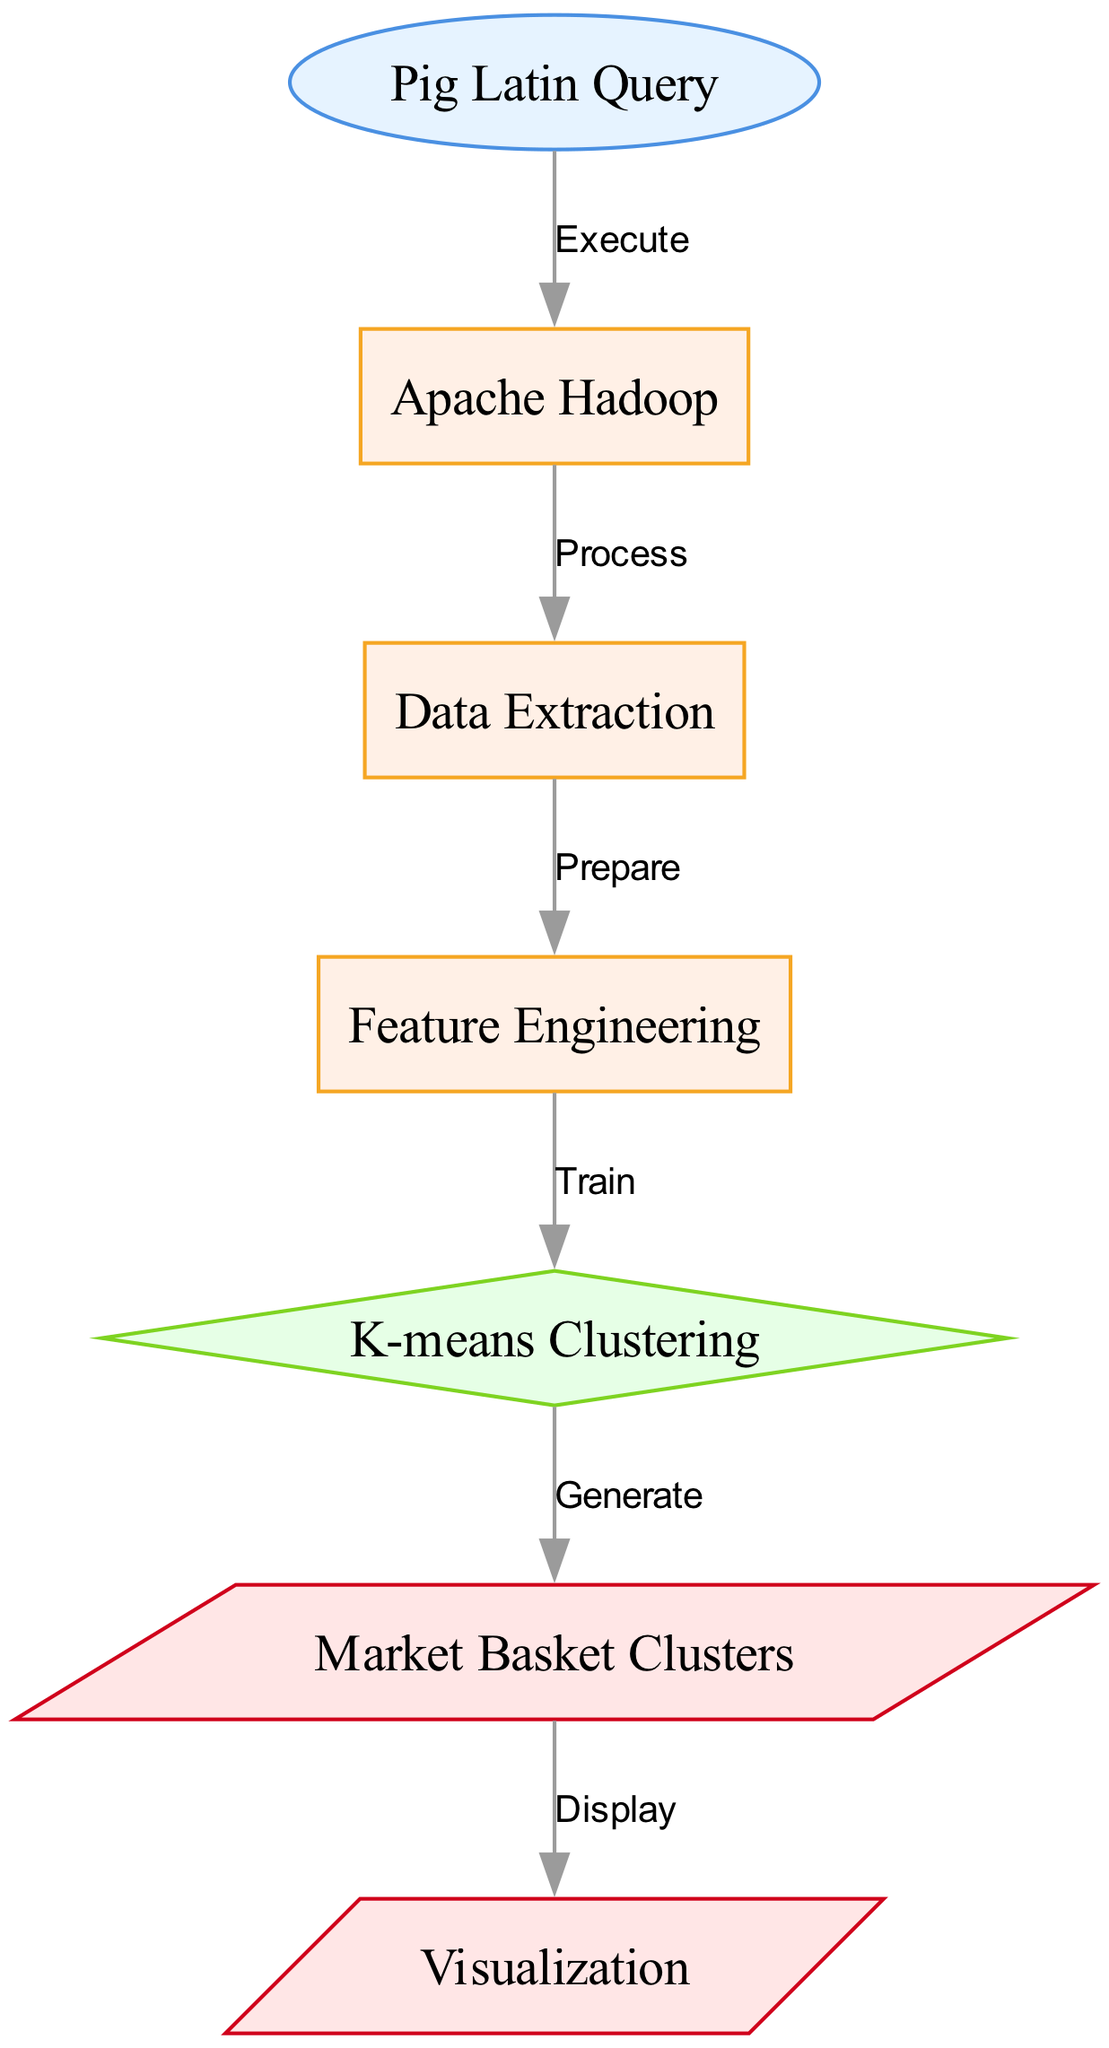What is the first node in the diagram? The first node in the diagram is labeled "Pig Latin Query," which is identified as an input type node. Therefore, it initiates the flow of the process as the starting point.
Answer: Pig Latin Query How many processing nodes are there in the diagram? There are three processing nodes in the diagram: "Apache Hadoop," "Data Extraction," and "Feature Engineering." These nodes represent various stages of data processing.
Answer: 3 What is the output generated by the K-means Clustering node? The K-means Clustering node generates "Market Basket Clusters," which is the immediate output from this model node in the diagram.
Answer: Market Basket Clusters Which node comes after "Feature Engineering"? The node that comes after "Feature Engineering" is "K-means Clustering." This indicates that after feature engineering, the next step is to apply the clustering algorithm.
Answer: K-means Clustering What type of node is "Visualization"? The node labeled "Visualization" is classified as an output type node, signifying that it represents the final step in the pipeline where results are displayed.
Answer: output 